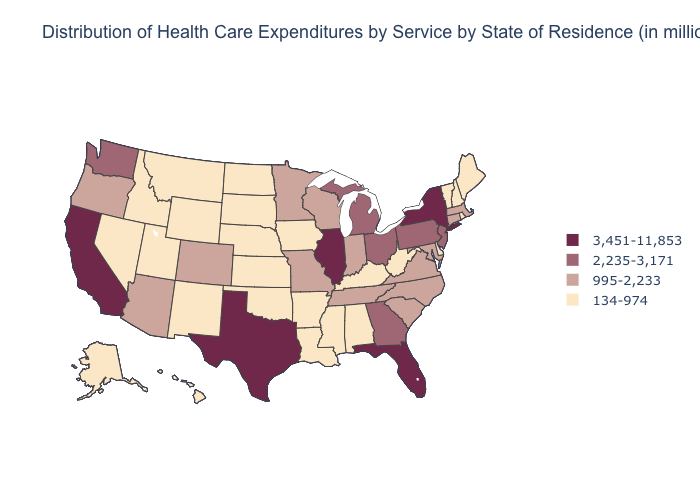How many symbols are there in the legend?
Quick response, please. 4. Among the states that border Massachusetts , which have the lowest value?
Answer briefly. New Hampshire, Rhode Island, Vermont. Does the map have missing data?
Answer briefly. No. Does New York have the highest value in the Northeast?
Be succinct. Yes. Is the legend a continuous bar?
Give a very brief answer. No. Name the states that have a value in the range 3,451-11,853?
Write a very short answer. California, Florida, Illinois, New York, Texas. What is the value of Indiana?
Concise answer only. 995-2,233. What is the value of North Carolina?
Quick response, please. 995-2,233. Does Delaware have the lowest value in the USA?
Keep it brief. Yes. What is the highest value in the USA?
Concise answer only. 3,451-11,853. Is the legend a continuous bar?
Answer briefly. No. What is the value of South Carolina?
Answer briefly. 995-2,233. Which states have the lowest value in the MidWest?
Short answer required. Iowa, Kansas, Nebraska, North Dakota, South Dakota. What is the value of Missouri?
Be succinct. 995-2,233. 